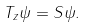Convert formula to latex. <formula><loc_0><loc_0><loc_500><loc_500>T _ { z } \psi = S \psi .</formula> 